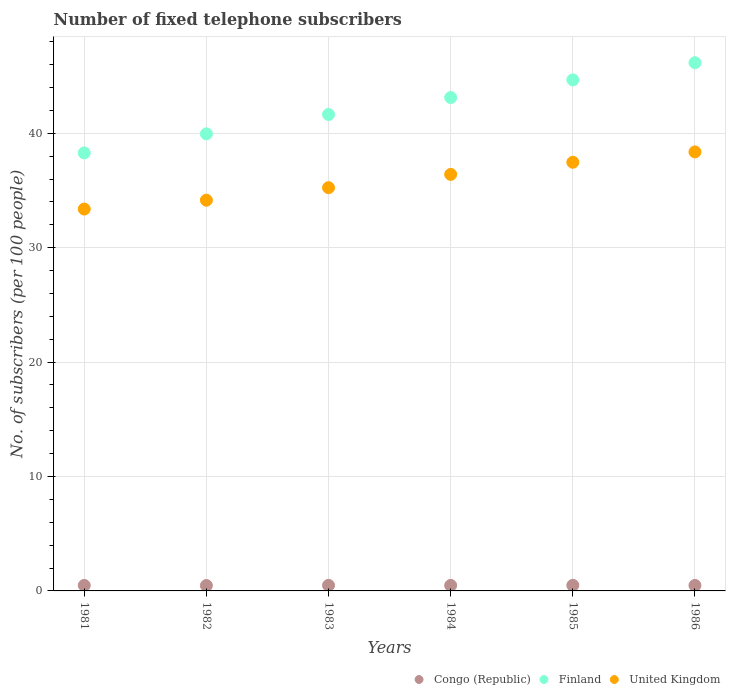How many different coloured dotlines are there?
Offer a terse response. 3. What is the number of fixed telephone subscribers in Congo (Republic) in 1986?
Your answer should be compact. 0.48. Across all years, what is the maximum number of fixed telephone subscribers in United Kingdom?
Your answer should be compact. 38.37. Across all years, what is the minimum number of fixed telephone subscribers in United Kingdom?
Your answer should be compact. 33.38. What is the total number of fixed telephone subscribers in United Kingdom in the graph?
Your answer should be compact. 215.02. What is the difference between the number of fixed telephone subscribers in Congo (Republic) in 1981 and that in 1986?
Your response must be concise. -0. What is the difference between the number of fixed telephone subscribers in United Kingdom in 1984 and the number of fixed telephone subscribers in Finland in 1981?
Your answer should be very brief. -1.88. What is the average number of fixed telephone subscribers in Finland per year?
Give a very brief answer. 42.31. In the year 1982, what is the difference between the number of fixed telephone subscribers in Congo (Republic) and number of fixed telephone subscribers in Finland?
Your answer should be very brief. -39.48. What is the ratio of the number of fixed telephone subscribers in United Kingdom in 1983 to that in 1985?
Offer a terse response. 0.94. Is the number of fixed telephone subscribers in Finland in 1983 less than that in 1986?
Your answer should be very brief. Yes. Is the difference between the number of fixed telephone subscribers in Congo (Republic) in 1981 and 1985 greater than the difference between the number of fixed telephone subscribers in Finland in 1981 and 1985?
Your answer should be very brief. Yes. What is the difference between the highest and the second highest number of fixed telephone subscribers in Congo (Republic)?
Your response must be concise. 0. What is the difference between the highest and the lowest number of fixed telephone subscribers in United Kingdom?
Give a very brief answer. 4.99. Is it the case that in every year, the sum of the number of fixed telephone subscribers in Congo (Republic) and number of fixed telephone subscribers in Finland  is greater than the number of fixed telephone subscribers in United Kingdom?
Provide a short and direct response. Yes. Does the number of fixed telephone subscribers in United Kingdom monotonically increase over the years?
Provide a succinct answer. Yes. Is the number of fixed telephone subscribers in United Kingdom strictly greater than the number of fixed telephone subscribers in Finland over the years?
Offer a terse response. No. Is the number of fixed telephone subscribers in Finland strictly less than the number of fixed telephone subscribers in Congo (Republic) over the years?
Ensure brevity in your answer.  No. How many dotlines are there?
Give a very brief answer. 3. How many years are there in the graph?
Your response must be concise. 6. Are the values on the major ticks of Y-axis written in scientific E-notation?
Your response must be concise. No. Does the graph contain any zero values?
Make the answer very short. No. Does the graph contain grids?
Provide a succinct answer. Yes. How many legend labels are there?
Ensure brevity in your answer.  3. What is the title of the graph?
Your answer should be very brief. Number of fixed telephone subscribers. What is the label or title of the Y-axis?
Offer a very short reply. No. of subscribers (per 100 people). What is the No. of subscribers (per 100 people) in Congo (Republic) in 1981?
Your answer should be very brief. 0.48. What is the No. of subscribers (per 100 people) in Finland in 1981?
Your answer should be very brief. 38.28. What is the No. of subscribers (per 100 people) in United Kingdom in 1981?
Give a very brief answer. 33.38. What is the No. of subscribers (per 100 people) in Congo (Republic) in 1982?
Your response must be concise. 0.47. What is the No. of subscribers (per 100 people) of Finland in 1982?
Your response must be concise. 39.95. What is the No. of subscribers (per 100 people) of United Kingdom in 1982?
Provide a succinct answer. 34.15. What is the No. of subscribers (per 100 people) in Congo (Republic) in 1983?
Give a very brief answer. 0.49. What is the No. of subscribers (per 100 people) in Finland in 1983?
Your response must be concise. 41.64. What is the No. of subscribers (per 100 people) of United Kingdom in 1983?
Give a very brief answer. 35.25. What is the No. of subscribers (per 100 people) of Congo (Republic) in 1984?
Offer a very short reply. 0.48. What is the No. of subscribers (per 100 people) in Finland in 1984?
Your answer should be compact. 43.12. What is the No. of subscribers (per 100 people) of United Kingdom in 1984?
Keep it short and to the point. 36.41. What is the No. of subscribers (per 100 people) in Congo (Republic) in 1985?
Provide a short and direct response. 0.49. What is the No. of subscribers (per 100 people) in Finland in 1985?
Your answer should be compact. 44.67. What is the No. of subscribers (per 100 people) of United Kingdom in 1985?
Provide a short and direct response. 37.47. What is the No. of subscribers (per 100 people) in Congo (Republic) in 1986?
Your answer should be very brief. 0.48. What is the No. of subscribers (per 100 people) of Finland in 1986?
Keep it short and to the point. 46.17. What is the No. of subscribers (per 100 people) of United Kingdom in 1986?
Your answer should be compact. 38.37. Across all years, what is the maximum No. of subscribers (per 100 people) in Congo (Republic)?
Give a very brief answer. 0.49. Across all years, what is the maximum No. of subscribers (per 100 people) in Finland?
Offer a very short reply. 46.17. Across all years, what is the maximum No. of subscribers (per 100 people) in United Kingdom?
Provide a short and direct response. 38.37. Across all years, what is the minimum No. of subscribers (per 100 people) of Congo (Republic)?
Keep it short and to the point. 0.47. Across all years, what is the minimum No. of subscribers (per 100 people) of Finland?
Give a very brief answer. 38.28. Across all years, what is the minimum No. of subscribers (per 100 people) of United Kingdom?
Ensure brevity in your answer.  33.38. What is the total No. of subscribers (per 100 people) of Congo (Republic) in the graph?
Your answer should be compact. 2.89. What is the total No. of subscribers (per 100 people) of Finland in the graph?
Provide a succinct answer. 253.83. What is the total No. of subscribers (per 100 people) of United Kingdom in the graph?
Ensure brevity in your answer.  215.02. What is the difference between the No. of subscribers (per 100 people) of Congo (Republic) in 1981 and that in 1982?
Your response must be concise. 0.01. What is the difference between the No. of subscribers (per 100 people) of Finland in 1981 and that in 1982?
Give a very brief answer. -1.66. What is the difference between the No. of subscribers (per 100 people) in United Kingdom in 1981 and that in 1982?
Provide a succinct answer. -0.77. What is the difference between the No. of subscribers (per 100 people) in Congo (Republic) in 1981 and that in 1983?
Give a very brief answer. -0.01. What is the difference between the No. of subscribers (per 100 people) of Finland in 1981 and that in 1983?
Make the answer very short. -3.36. What is the difference between the No. of subscribers (per 100 people) in United Kingdom in 1981 and that in 1983?
Make the answer very short. -1.87. What is the difference between the No. of subscribers (per 100 people) of Congo (Republic) in 1981 and that in 1984?
Offer a very short reply. -0. What is the difference between the No. of subscribers (per 100 people) of Finland in 1981 and that in 1984?
Make the answer very short. -4.84. What is the difference between the No. of subscribers (per 100 people) of United Kingdom in 1981 and that in 1984?
Provide a short and direct response. -3.03. What is the difference between the No. of subscribers (per 100 people) of Congo (Republic) in 1981 and that in 1985?
Offer a very short reply. -0.01. What is the difference between the No. of subscribers (per 100 people) of Finland in 1981 and that in 1985?
Your response must be concise. -6.38. What is the difference between the No. of subscribers (per 100 people) in United Kingdom in 1981 and that in 1985?
Offer a very short reply. -4.09. What is the difference between the No. of subscribers (per 100 people) of Congo (Republic) in 1981 and that in 1986?
Keep it short and to the point. -0. What is the difference between the No. of subscribers (per 100 people) of Finland in 1981 and that in 1986?
Your answer should be compact. -7.88. What is the difference between the No. of subscribers (per 100 people) in United Kingdom in 1981 and that in 1986?
Ensure brevity in your answer.  -4.99. What is the difference between the No. of subscribers (per 100 people) in Congo (Republic) in 1982 and that in 1983?
Give a very brief answer. -0.02. What is the difference between the No. of subscribers (per 100 people) of Finland in 1982 and that in 1983?
Make the answer very short. -1.69. What is the difference between the No. of subscribers (per 100 people) in United Kingdom in 1982 and that in 1983?
Keep it short and to the point. -1.09. What is the difference between the No. of subscribers (per 100 people) of Congo (Republic) in 1982 and that in 1984?
Give a very brief answer. -0.01. What is the difference between the No. of subscribers (per 100 people) in Finland in 1982 and that in 1984?
Ensure brevity in your answer.  -3.17. What is the difference between the No. of subscribers (per 100 people) in United Kingdom in 1982 and that in 1984?
Provide a short and direct response. -2.25. What is the difference between the No. of subscribers (per 100 people) in Congo (Republic) in 1982 and that in 1985?
Provide a short and direct response. -0.02. What is the difference between the No. of subscribers (per 100 people) of Finland in 1982 and that in 1985?
Make the answer very short. -4.72. What is the difference between the No. of subscribers (per 100 people) in United Kingdom in 1982 and that in 1985?
Keep it short and to the point. -3.32. What is the difference between the No. of subscribers (per 100 people) in Congo (Republic) in 1982 and that in 1986?
Provide a succinct answer. -0.01. What is the difference between the No. of subscribers (per 100 people) in Finland in 1982 and that in 1986?
Give a very brief answer. -6.22. What is the difference between the No. of subscribers (per 100 people) of United Kingdom in 1982 and that in 1986?
Make the answer very short. -4.22. What is the difference between the No. of subscribers (per 100 people) in Congo (Republic) in 1983 and that in 1984?
Make the answer very short. 0. What is the difference between the No. of subscribers (per 100 people) of Finland in 1983 and that in 1984?
Make the answer very short. -1.48. What is the difference between the No. of subscribers (per 100 people) in United Kingdom in 1983 and that in 1984?
Your answer should be very brief. -1.16. What is the difference between the No. of subscribers (per 100 people) in Congo (Republic) in 1983 and that in 1985?
Make the answer very short. -0. What is the difference between the No. of subscribers (per 100 people) of Finland in 1983 and that in 1985?
Ensure brevity in your answer.  -3.02. What is the difference between the No. of subscribers (per 100 people) in United Kingdom in 1983 and that in 1985?
Provide a short and direct response. -2.22. What is the difference between the No. of subscribers (per 100 people) of Congo (Republic) in 1983 and that in 1986?
Keep it short and to the point. 0. What is the difference between the No. of subscribers (per 100 people) in Finland in 1983 and that in 1986?
Your answer should be very brief. -4.52. What is the difference between the No. of subscribers (per 100 people) of United Kingdom in 1983 and that in 1986?
Make the answer very short. -3.13. What is the difference between the No. of subscribers (per 100 people) of Congo (Republic) in 1984 and that in 1985?
Your answer should be very brief. -0.01. What is the difference between the No. of subscribers (per 100 people) of Finland in 1984 and that in 1985?
Make the answer very short. -1.55. What is the difference between the No. of subscribers (per 100 people) in United Kingdom in 1984 and that in 1985?
Give a very brief answer. -1.06. What is the difference between the No. of subscribers (per 100 people) in Congo (Republic) in 1984 and that in 1986?
Ensure brevity in your answer.  0. What is the difference between the No. of subscribers (per 100 people) in Finland in 1984 and that in 1986?
Ensure brevity in your answer.  -3.05. What is the difference between the No. of subscribers (per 100 people) of United Kingdom in 1984 and that in 1986?
Provide a succinct answer. -1.97. What is the difference between the No. of subscribers (per 100 people) of Congo (Republic) in 1985 and that in 1986?
Provide a short and direct response. 0.01. What is the difference between the No. of subscribers (per 100 people) of Finland in 1985 and that in 1986?
Give a very brief answer. -1.5. What is the difference between the No. of subscribers (per 100 people) of United Kingdom in 1985 and that in 1986?
Your response must be concise. -0.9. What is the difference between the No. of subscribers (per 100 people) in Congo (Republic) in 1981 and the No. of subscribers (per 100 people) in Finland in 1982?
Keep it short and to the point. -39.47. What is the difference between the No. of subscribers (per 100 people) of Congo (Republic) in 1981 and the No. of subscribers (per 100 people) of United Kingdom in 1982?
Provide a short and direct response. -33.67. What is the difference between the No. of subscribers (per 100 people) of Finland in 1981 and the No. of subscribers (per 100 people) of United Kingdom in 1982?
Make the answer very short. 4.13. What is the difference between the No. of subscribers (per 100 people) of Congo (Republic) in 1981 and the No. of subscribers (per 100 people) of Finland in 1983?
Give a very brief answer. -41.16. What is the difference between the No. of subscribers (per 100 people) in Congo (Republic) in 1981 and the No. of subscribers (per 100 people) in United Kingdom in 1983?
Your answer should be compact. -34.77. What is the difference between the No. of subscribers (per 100 people) of Finland in 1981 and the No. of subscribers (per 100 people) of United Kingdom in 1983?
Keep it short and to the point. 3.04. What is the difference between the No. of subscribers (per 100 people) of Congo (Republic) in 1981 and the No. of subscribers (per 100 people) of Finland in 1984?
Provide a succinct answer. -42.64. What is the difference between the No. of subscribers (per 100 people) in Congo (Republic) in 1981 and the No. of subscribers (per 100 people) in United Kingdom in 1984?
Offer a very short reply. -35.93. What is the difference between the No. of subscribers (per 100 people) of Finland in 1981 and the No. of subscribers (per 100 people) of United Kingdom in 1984?
Make the answer very short. 1.88. What is the difference between the No. of subscribers (per 100 people) of Congo (Republic) in 1981 and the No. of subscribers (per 100 people) of Finland in 1985?
Your response must be concise. -44.19. What is the difference between the No. of subscribers (per 100 people) of Congo (Republic) in 1981 and the No. of subscribers (per 100 people) of United Kingdom in 1985?
Offer a terse response. -36.99. What is the difference between the No. of subscribers (per 100 people) of Finland in 1981 and the No. of subscribers (per 100 people) of United Kingdom in 1985?
Provide a short and direct response. 0.82. What is the difference between the No. of subscribers (per 100 people) in Congo (Republic) in 1981 and the No. of subscribers (per 100 people) in Finland in 1986?
Give a very brief answer. -45.69. What is the difference between the No. of subscribers (per 100 people) of Congo (Republic) in 1981 and the No. of subscribers (per 100 people) of United Kingdom in 1986?
Make the answer very short. -37.89. What is the difference between the No. of subscribers (per 100 people) in Finland in 1981 and the No. of subscribers (per 100 people) in United Kingdom in 1986?
Make the answer very short. -0.09. What is the difference between the No. of subscribers (per 100 people) of Congo (Republic) in 1982 and the No. of subscribers (per 100 people) of Finland in 1983?
Ensure brevity in your answer.  -41.17. What is the difference between the No. of subscribers (per 100 people) of Congo (Republic) in 1982 and the No. of subscribers (per 100 people) of United Kingdom in 1983?
Provide a succinct answer. -34.77. What is the difference between the No. of subscribers (per 100 people) of Finland in 1982 and the No. of subscribers (per 100 people) of United Kingdom in 1983?
Your response must be concise. 4.7. What is the difference between the No. of subscribers (per 100 people) in Congo (Republic) in 1982 and the No. of subscribers (per 100 people) in Finland in 1984?
Ensure brevity in your answer.  -42.65. What is the difference between the No. of subscribers (per 100 people) in Congo (Republic) in 1982 and the No. of subscribers (per 100 people) in United Kingdom in 1984?
Keep it short and to the point. -35.94. What is the difference between the No. of subscribers (per 100 people) in Finland in 1982 and the No. of subscribers (per 100 people) in United Kingdom in 1984?
Give a very brief answer. 3.54. What is the difference between the No. of subscribers (per 100 people) in Congo (Republic) in 1982 and the No. of subscribers (per 100 people) in Finland in 1985?
Offer a terse response. -44.2. What is the difference between the No. of subscribers (per 100 people) in Congo (Republic) in 1982 and the No. of subscribers (per 100 people) in United Kingdom in 1985?
Provide a succinct answer. -37. What is the difference between the No. of subscribers (per 100 people) in Finland in 1982 and the No. of subscribers (per 100 people) in United Kingdom in 1985?
Keep it short and to the point. 2.48. What is the difference between the No. of subscribers (per 100 people) of Congo (Republic) in 1982 and the No. of subscribers (per 100 people) of Finland in 1986?
Offer a very short reply. -45.7. What is the difference between the No. of subscribers (per 100 people) of Congo (Republic) in 1982 and the No. of subscribers (per 100 people) of United Kingdom in 1986?
Keep it short and to the point. -37.9. What is the difference between the No. of subscribers (per 100 people) in Finland in 1982 and the No. of subscribers (per 100 people) in United Kingdom in 1986?
Offer a very short reply. 1.58. What is the difference between the No. of subscribers (per 100 people) in Congo (Republic) in 1983 and the No. of subscribers (per 100 people) in Finland in 1984?
Keep it short and to the point. -42.64. What is the difference between the No. of subscribers (per 100 people) in Congo (Republic) in 1983 and the No. of subscribers (per 100 people) in United Kingdom in 1984?
Provide a succinct answer. -35.92. What is the difference between the No. of subscribers (per 100 people) of Finland in 1983 and the No. of subscribers (per 100 people) of United Kingdom in 1984?
Provide a succinct answer. 5.24. What is the difference between the No. of subscribers (per 100 people) of Congo (Republic) in 1983 and the No. of subscribers (per 100 people) of Finland in 1985?
Your answer should be very brief. -44.18. What is the difference between the No. of subscribers (per 100 people) of Congo (Republic) in 1983 and the No. of subscribers (per 100 people) of United Kingdom in 1985?
Provide a succinct answer. -36.98. What is the difference between the No. of subscribers (per 100 people) in Finland in 1983 and the No. of subscribers (per 100 people) in United Kingdom in 1985?
Give a very brief answer. 4.18. What is the difference between the No. of subscribers (per 100 people) in Congo (Republic) in 1983 and the No. of subscribers (per 100 people) in Finland in 1986?
Offer a very short reply. -45.68. What is the difference between the No. of subscribers (per 100 people) in Congo (Republic) in 1983 and the No. of subscribers (per 100 people) in United Kingdom in 1986?
Provide a short and direct response. -37.88. What is the difference between the No. of subscribers (per 100 people) in Finland in 1983 and the No. of subscribers (per 100 people) in United Kingdom in 1986?
Give a very brief answer. 3.27. What is the difference between the No. of subscribers (per 100 people) of Congo (Republic) in 1984 and the No. of subscribers (per 100 people) of Finland in 1985?
Keep it short and to the point. -44.18. What is the difference between the No. of subscribers (per 100 people) of Congo (Republic) in 1984 and the No. of subscribers (per 100 people) of United Kingdom in 1985?
Your response must be concise. -36.98. What is the difference between the No. of subscribers (per 100 people) in Finland in 1984 and the No. of subscribers (per 100 people) in United Kingdom in 1985?
Your answer should be compact. 5.65. What is the difference between the No. of subscribers (per 100 people) of Congo (Republic) in 1984 and the No. of subscribers (per 100 people) of Finland in 1986?
Ensure brevity in your answer.  -45.68. What is the difference between the No. of subscribers (per 100 people) of Congo (Republic) in 1984 and the No. of subscribers (per 100 people) of United Kingdom in 1986?
Give a very brief answer. -37.89. What is the difference between the No. of subscribers (per 100 people) of Finland in 1984 and the No. of subscribers (per 100 people) of United Kingdom in 1986?
Your response must be concise. 4.75. What is the difference between the No. of subscribers (per 100 people) in Congo (Republic) in 1985 and the No. of subscribers (per 100 people) in Finland in 1986?
Your answer should be very brief. -45.68. What is the difference between the No. of subscribers (per 100 people) in Congo (Republic) in 1985 and the No. of subscribers (per 100 people) in United Kingdom in 1986?
Give a very brief answer. -37.88. What is the difference between the No. of subscribers (per 100 people) in Finland in 1985 and the No. of subscribers (per 100 people) in United Kingdom in 1986?
Provide a succinct answer. 6.3. What is the average No. of subscribers (per 100 people) in Congo (Republic) per year?
Keep it short and to the point. 0.48. What is the average No. of subscribers (per 100 people) in Finland per year?
Give a very brief answer. 42.31. What is the average No. of subscribers (per 100 people) in United Kingdom per year?
Your answer should be very brief. 35.84. In the year 1981, what is the difference between the No. of subscribers (per 100 people) of Congo (Republic) and No. of subscribers (per 100 people) of Finland?
Keep it short and to the point. -37.8. In the year 1981, what is the difference between the No. of subscribers (per 100 people) in Congo (Republic) and No. of subscribers (per 100 people) in United Kingdom?
Keep it short and to the point. -32.9. In the year 1981, what is the difference between the No. of subscribers (per 100 people) in Finland and No. of subscribers (per 100 people) in United Kingdom?
Provide a succinct answer. 4.91. In the year 1982, what is the difference between the No. of subscribers (per 100 people) in Congo (Republic) and No. of subscribers (per 100 people) in Finland?
Your answer should be compact. -39.48. In the year 1982, what is the difference between the No. of subscribers (per 100 people) of Congo (Republic) and No. of subscribers (per 100 people) of United Kingdom?
Provide a short and direct response. -33.68. In the year 1982, what is the difference between the No. of subscribers (per 100 people) in Finland and No. of subscribers (per 100 people) in United Kingdom?
Give a very brief answer. 5.8. In the year 1983, what is the difference between the No. of subscribers (per 100 people) in Congo (Republic) and No. of subscribers (per 100 people) in Finland?
Give a very brief answer. -41.16. In the year 1983, what is the difference between the No. of subscribers (per 100 people) of Congo (Republic) and No. of subscribers (per 100 people) of United Kingdom?
Your answer should be compact. -34.76. In the year 1983, what is the difference between the No. of subscribers (per 100 people) of Finland and No. of subscribers (per 100 people) of United Kingdom?
Your answer should be compact. 6.4. In the year 1984, what is the difference between the No. of subscribers (per 100 people) of Congo (Republic) and No. of subscribers (per 100 people) of Finland?
Offer a terse response. -42.64. In the year 1984, what is the difference between the No. of subscribers (per 100 people) of Congo (Republic) and No. of subscribers (per 100 people) of United Kingdom?
Provide a short and direct response. -35.92. In the year 1984, what is the difference between the No. of subscribers (per 100 people) of Finland and No. of subscribers (per 100 people) of United Kingdom?
Ensure brevity in your answer.  6.72. In the year 1985, what is the difference between the No. of subscribers (per 100 people) of Congo (Republic) and No. of subscribers (per 100 people) of Finland?
Provide a succinct answer. -44.18. In the year 1985, what is the difference between the No. of subscribers (per 100 people) of Congo (Republic) and No. of subscribers (per 100 people) of United Kingdom?
Give a very brief answer. -36.98. In the year 1985, what is the difference between the No. of subscribers (per 100 people) of Finland and No. of subscribers (per 100 people) of United Kingdom?
Keep it short and to the point. 7.2. In the year 1986, what is the difference between the No. of subscribers (per 100 people) of Congo (Republic) and No. of subscribers (per 100 people) of Finland?
Offer a terse response. -45.68. In the year 1986, what is the difference between the No. of subscribers (per 100 people) in Congo (Republic) and No. of subscribers (per 100 people) in United Kingdom?
Make the answer very short. -37.89. In the year 1986, what is the difference between the No. of subscribers (per 100 people) in Finland and No. of subscribers (per 100 people) in United Kingdom?
Give a very brief answer. 7.8. What is the ratio of the No. of subscribers (per 100 people) of Congo (Republic) in 1981 to that in 1982?
Ensure brevity in your answer.  1.02. What is the ratio of the No. of subscribers (per 100 people) in United Kingdom in 1981 to that in 1982?
Keep it short and to the point. 0.98. What is the ratio of the No. of subscribers (per 100 people) of Congo (Republic) in 1981 to that in 1983?
Make the answer very short. 0.99. What is the ratio of the No. of subscribers (per 100 people) of Finland in 1981 to that in 1983?
Provide a succinct answer. 0.92. What is the ratio of the No. of subscribers (per 100 people) in United Kingdom in 1981 to that in 1983?
Give a very brief answer. 0.95. What is the ratio of the No. of subscribers (per 100 people) of Finland in 1981 to that in 1984?
Give a very brief answer. 0.89. What is the ratio of the No. of subscribers (per 100 people) in United Kingdom in 1981 to that in 1984?
Provide a short and direct response. 0.92. What is the ratio of the No. of subscribers (per 100 people) of Congo (Republic) in 1981 to that in 1985?
Your answer should be compact. 0.98. What is the ratio of the No. of subscribers (per 100 people) in Finland in 1981 to that in 1985?
Your response must be concise. 0.86. What is the ratio of the No. of subscribers (per 100 people) of United Kingdom in 1981 to that in 1985?
Offer a terse response. 0.89. What is the ratio of the No. of subscribers (per 100 people) in Congo (Republic) in 1981 to that in 1986?
Provide a short and direct response. 1. What is the ratio of the No. of subscribers (per 100 people) in Finland in 1981 to that in 1986?
Your answer should be compact. 0.83. What is the ratio of the No. of subscribers (per 100 people) of United Kingdom in 1981 to that in 1986?
Provide a succinct answer. 0.87. What is the ratio of the No. of subscribers (per 100 people) of Congo (Republic) in 1982 to that in 1983?
Your answer should be compact. 0.97. What is the ratio of the No. of subscribers (per 100 people) of Finland in 1982 to that in 1983?
Your response must be concise. 0.96. What is the ratio of the No. of subscribers (per 100 people) in United Kingdom in 1982 to that in 1983?
Make the answer very short. 0.97. What is the ratio of the No. of subscribers (per 100 people) in Congo (Republic) in 1982 to that in 1984?
Keep it short and to the point. 0.97. What is the ratio of the No. of subscribers (per 100 people) in Finland in 1982 to that in 1984?
Offer a very short reply. 0.93. What is the ratio of the No. of subscribers (per 100 people) in United Kingdom in 1982 to that in 1984?
Provide a short and direct response. 0.94. What is the ratio of the No. of subscribers (per 100 people) in Congo (Republic) in 1982 to that in 1985?
Offer a very short reply. 0.96. What is the ratio of the No. of subscribers (per 100 people) of Finland in 1982 to that in 1985?
Ensure brevity in your answer.  0.89. What is the ratio of the No. of subscribers (per 100 people) in United Kingdom in 1982 to that in 1985?
Offer a terse response. 0.91. What is the ratio of the No. of subscribers (per 100 people) of Congo (Republic) in 1982 to that in 1986?
Your answer should be very brief. 0.98. What is the ratio of the No. of subscribers (per 100 people) of Finland in 1982 to that in 1986?
Your response must be concise. 0.87. What is the ratio of the No. of subscribers (per 100 people) of United Kingdom in 1982 to that in 1986?
Your response must be concise. 0.89. What is the ratio of the No. of subscribers (per 100 people) of Finland in 1983 to that in 1984?
Keep it short and to the point. 0.97. What is the ratio of the No. of subscribers (per 100 people) of United Kingdom in 1983 to that in 1984?
Your response must be concise. 0.97. What is the ratio of the No. of subscribers (per 100 people) in Finland in 1983 to that in 1985?
Your answer should be very brief. 0.93. What is the ratio of the No. of subscribers (per 100 people) in United Kingdom in 1983 to that in 1985?
Give a very brief answer. 0.94. What is the ratio of the No. of subscribers (per 100 people) in Congo (Republic) in 1983 to that in 1986?
Give a very brief answer. 1.01. What is the ratio of the No. of subscribers (per 100 people) in Finland in 1983 to that in 1986?
Offer a terse response. 0.9. What is the ratio of the No. of subscribers (per 100 people) of United Kingdom in 1983 to that in 1986?
Ensure brevity in your answer.  0.92. What is the ratio of the No. of subscribers (per 100 people) of Congo (Republic) in 1984 to that in 1985?
Make the answer very short. 0.99. What is the ratio of the No. of subscribers (per 100 people) of Finland in 1984 to that in 1985?
Provide a short and direct response. 0.97. What is the ratio of the No. of subscribers (per 100 people) in United Kingdom in 1984 to that in 1985?
Keep it short and to the point. 0.97. What is the ratio of the No. of subscribers (per 100 people) in Congo (Republic) in 1984 to that in 1986?
Keep it short and to the point. 1. What is the ratio of the No. of subscribers (per 100 people) of Finland in 1984 to that in 1986?
Ensure brevity in your answer.  0.93. What is the ratio of the No. of subscribers (per 100 people) in United Kingdom in 1984 to that in 1986?
Offer a terse response. 0.95. What is the ratio of the No. of subscribers (per 100 people) in Congo (Republic) in 1985 to that in 1986?
Your response must be concise. 1.01. What is the ratio of the No. of subscribers (per 100 people) of Finland in 1985 to that in 1986?
Provide a succinct answer. 0.97. What is the ratio of the No. of subscribers (per 100 people) of United Kingdom in 1985 to that in 1986?
Give a very brief answer. 0.98. What is the difference between the highest and the second highest No. of subscribers (per 100 people) in Congo (Republic)?
Provide a short and direct response. 0. What is the difference between the highest and the second highest No. of subscribers (per 100 people) of Finland?
Keep it short and to the point. 1.5. What is the difference between the highest and the second highest No. of subscribers (per 100 people) in United Kingdom?
Provide a succinct answer. 0.9. What is the difference between the highest and the lowest No. of subscribers (per 100 people) in Congo (Republic)?
Ensure brevity in your answer.  0.02. What is the difference between the highest and the lowest No. of subscribers (per 100 people) of Finland?
Give a very brief answer. 7.88. What is the difference between the highest and the lowest No. of subscribers (per 100 people) in United Kingdom?
Provide a short and direct response. 4.99. 